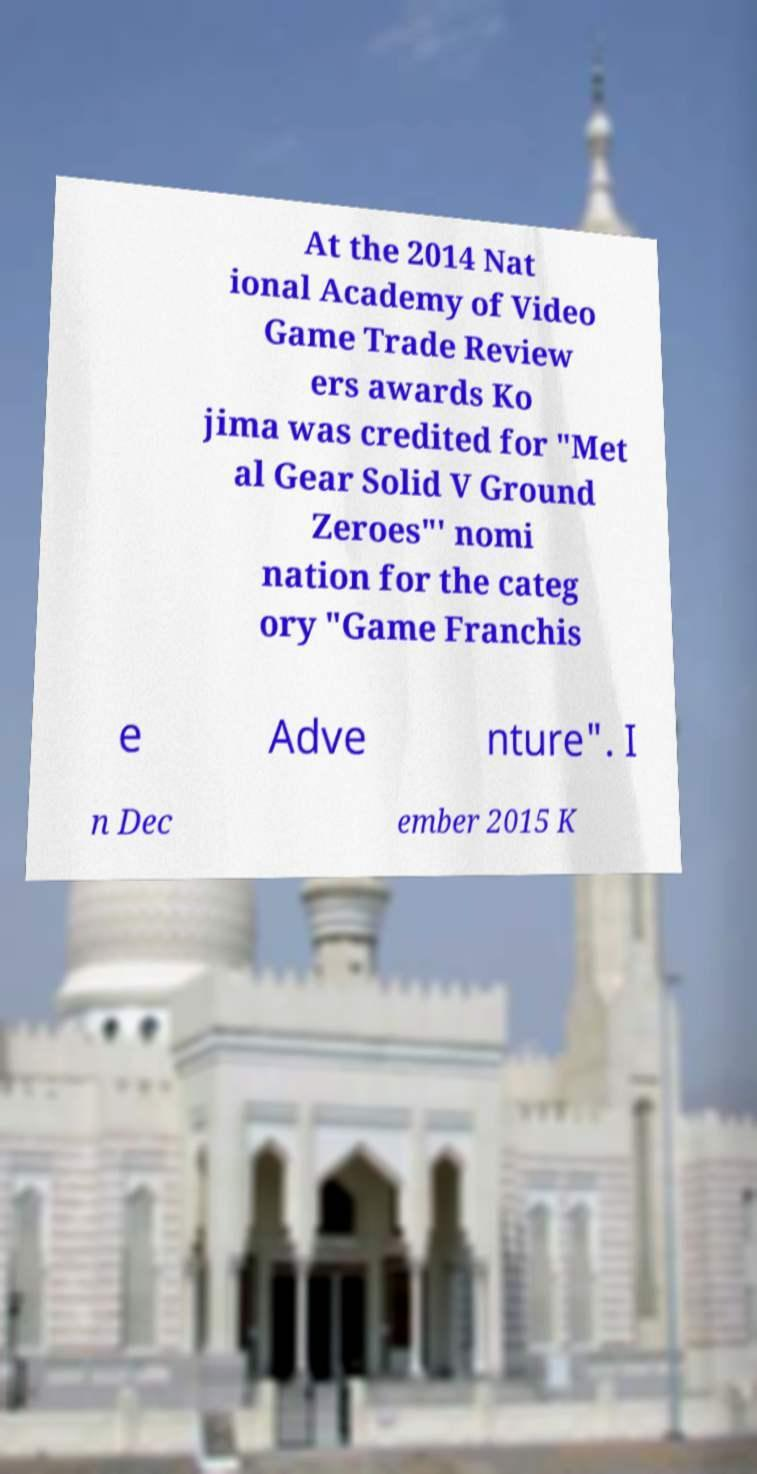Could you extract and type out the text from this image? At the 2014 Nat ional Academy of Video Game Trade Review ers awards Ko jima was credited for "Met al Gear Solid V Ground Zeroes"' nomi nation for the categ ory "Game Franchis e Adve nture". I n Dec ember 2015 K 